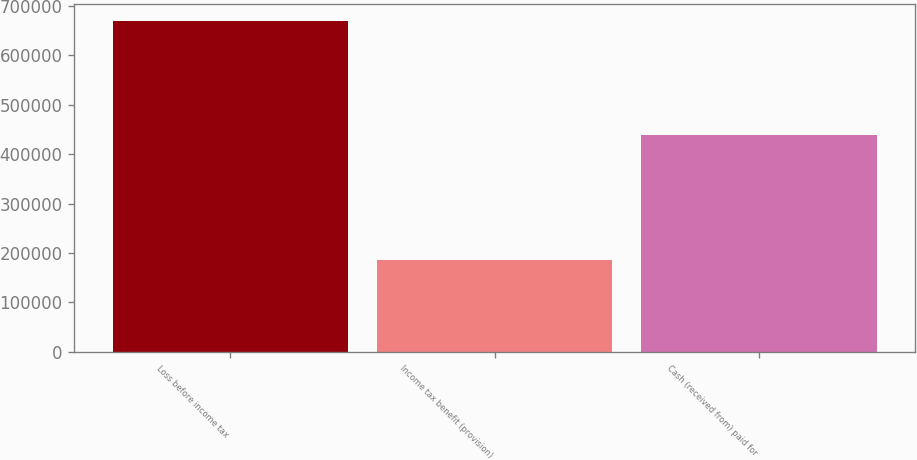Convert chart to OTSL. <chart><loc_0><loc_0><loc_500><loc_500><bar_chart><fcel>Loss before income tax<fcel>Income tax benefit (provision)<fcel>Cash (received from) paid for<nl><fcel>668988<fcel>186298<fcel>437874<nl></chart> 